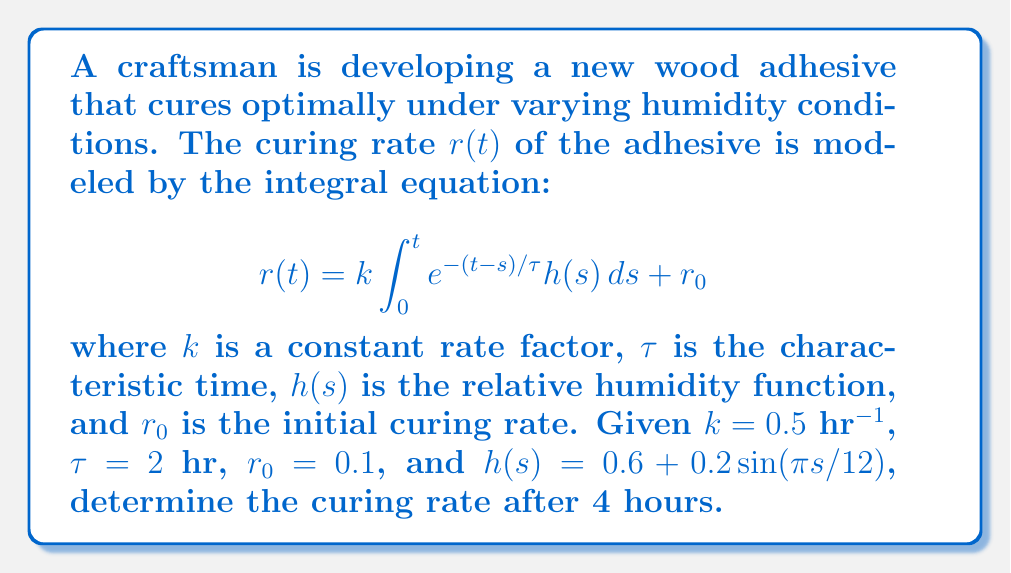Can you answer this question? To solve this problem, we'll follow these steps:

1) First, we need to evaluate the integral in the given equation:

   $$\int_0^t e^{-(t-s)/\tau} h(s) ds$$

2) Substituting the given function for $h(s)$:

   $$\int_0^4 e^{-(4-s)/2} (0.6 + 0.2\sin(πs/12)) ds$$

3) This integral doesn't have a simple analytical solution, so we'll use numerical integration. We can use Simpson's rule with a small step size (e.g., 0.01) for accuracy.

4) After numerical integration, we get approximately:

   $$\int_0^4 e^{-(4-s)/2} (0.6 + 0.2\sin(πs/12)) ds \approx 2.7416$$

5) Now we can substitute this result, along with the given values, into the original equation:

   $$r(4) = 0.5 \cdot 2.7416 + 0.1$$

6) Calculating the final result:

   $$r(4) = 1.3708 + 0.1 = 1.4708$$

Therefore, the curing rate after 4 hours is approximately 1.4708.
Answer: 1.4708 